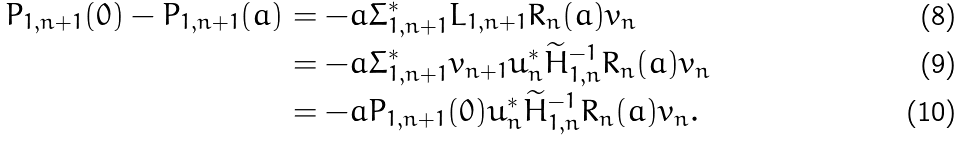Convert formula to latex. <formula><loc_0><loc_0><loc_500><loc_500>P _ { 1 , n + 1 } ( 0 ) - P _ { 1 , n + 1 } ( a ) & = - a \Sigma _ { 1 , n + 1 } ^ { * } L _ { 1 , n + 1 } R _ { n } ( a ) v _ { n } \\ & = - a \Sigma _ { 1 , n + 1 } ^ { * } v _ { n + 1 } u _ { n } ^ { * } \widetilde { H } _ { 1 , n } ^ { - 1 } R _ { n } ( a ) v _ { n } \\ & = - a P _ { 1 , n + 1 } ( 0 ) u _ { n } ^ { * } \widetilde { H } _ { 1 , n } ^ { - 1 } R _ { n } ( a ) v _ { n } .</formula> 